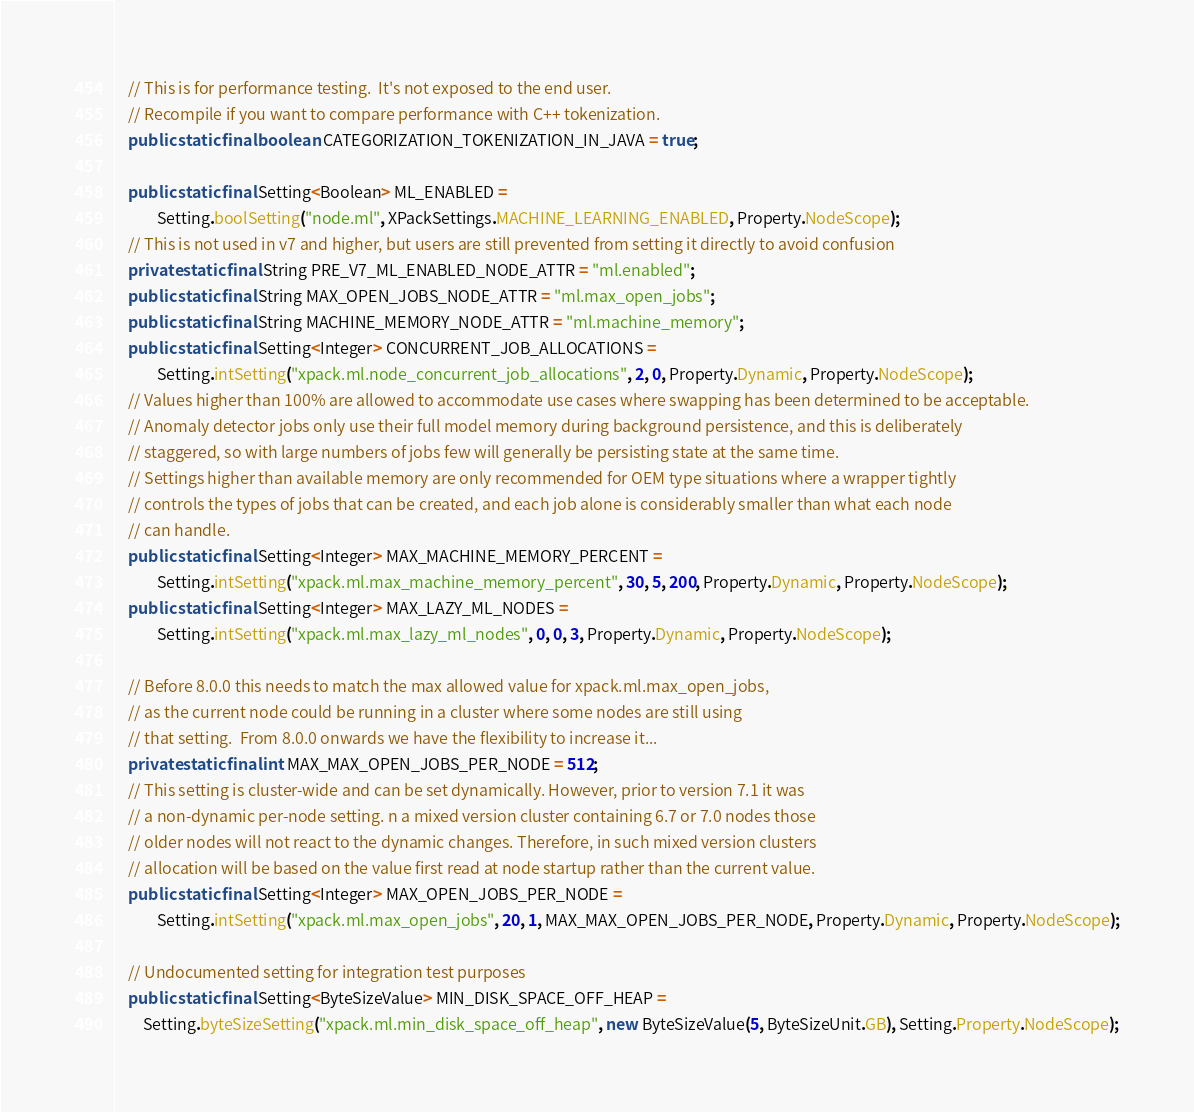Convert code to text. <code><loc_0><loc_0><loc_500><loc_500><_Java_>    // This is for performance testing.  It's not exposed to the end user.
    // Recompile if you want to compare performance with C++ tokenization.
    public static final boolean CATEGORIZATION_TOKENIZATION_IN_JAVA = true;

    public static final Setting<Boolean> ML_ENABLED =
            Setting.boolSetting("node.ml", XPackSettings.MACHINE_LEARNING_ENABLED, Property.NodeScope);
    // This is not used in v7 and higher, but users are still prevented from setting it directly to avoid confusion
    private static final String PRE_V7_ML_ENABLED_NODE_ATTR = "ml.enabled";
    public static final String MAX_OPEN_JOBS_NODE_ATTR = "ml.max_open_jobs";
    public static final String MACHINE_MEMORY_NODE_ATTR = "ml.machine_memory";
    public static final Setting<Integer> CONCURRENT_JOB_ALLOCATIONS =
            Setting.intSetting("xpack.ml.node_concurrent_job_allocations", 2, 0, Property.Dynamic, Property.NodeScope);
    // Values higher than 100% are allowed to accommodate use cases where swapping has been determined to be acceptable.
    // Anomaly detector jobs only use their full model memory during background persistence, and this is deliberately
    // staggered, so with large numbers of jobs few will generally be persisting state at the same time.
    // Settings higher than available memory are only recommended for OEM type situations where a wrapper tightly
    // controls the types of jobs that can be created, and each job alone is considerably smaller than what each node
    // can handle.
    public static final Setting<Integer> MAX_MACHINE_MEMORY_PERCENT =
            Setting.intSetting("xpack.ml.max_machine_memory_percent", 30, 5, 200, Property.Dynamic, Property.NodeScope);
    public static final Setting<Integer> MAX_LAZY_ML_NODES =
            Setting.intSetting("xpack.ml.max_lazy_ml_nodes", 0, 0, 3, Property.Dynamic, Property.NodeScope);

    // Before 8.0.0 this needs to match the max allowed value for xpack.ml.max_open_jobs,
    // as the current node could be running in a cluster where some nodes are still using
    // that setting.  From 8.0.0 onwards we have the flexibility to increase it...
    private static final int MAX_MAX_OPEN_JOBS_PER_NODE = 512;
    // This setting is cluster-wide and can be set dynamically. However, prior to version 7.1 it was
    // a non-dynamic per-node setting. n a mixed version cluster containing 6.7 or 7.0 nodes those
    // older nodes will not react to the dynamic changes. Therefore, in such mixed version clusters
    // allocation will be based on the value first read at node startup rather than the current value.
    public static final Setting<Integer> MAX_OPEN_JOBS_PER_NODE =
            Setting.intSetting("xpack.ml.max_open_jobs", 20, 1, MAX_MAX_OPEN_JOBS_PER_NODE, Property.Dynamic, Property.NodeScope);

    // Undocumented setting for integration test purposes
    public static final Setting<ByteSizeValue> MIN_DISK_SPACE_OFF_HEAP =
        Setting.byteSizeSetting("xpack.ml.min_disk_space_off_heap", new ByteSizeValue(5, ByteSizeUnit.GB), Setting.Property.NodeScope);
</code> 